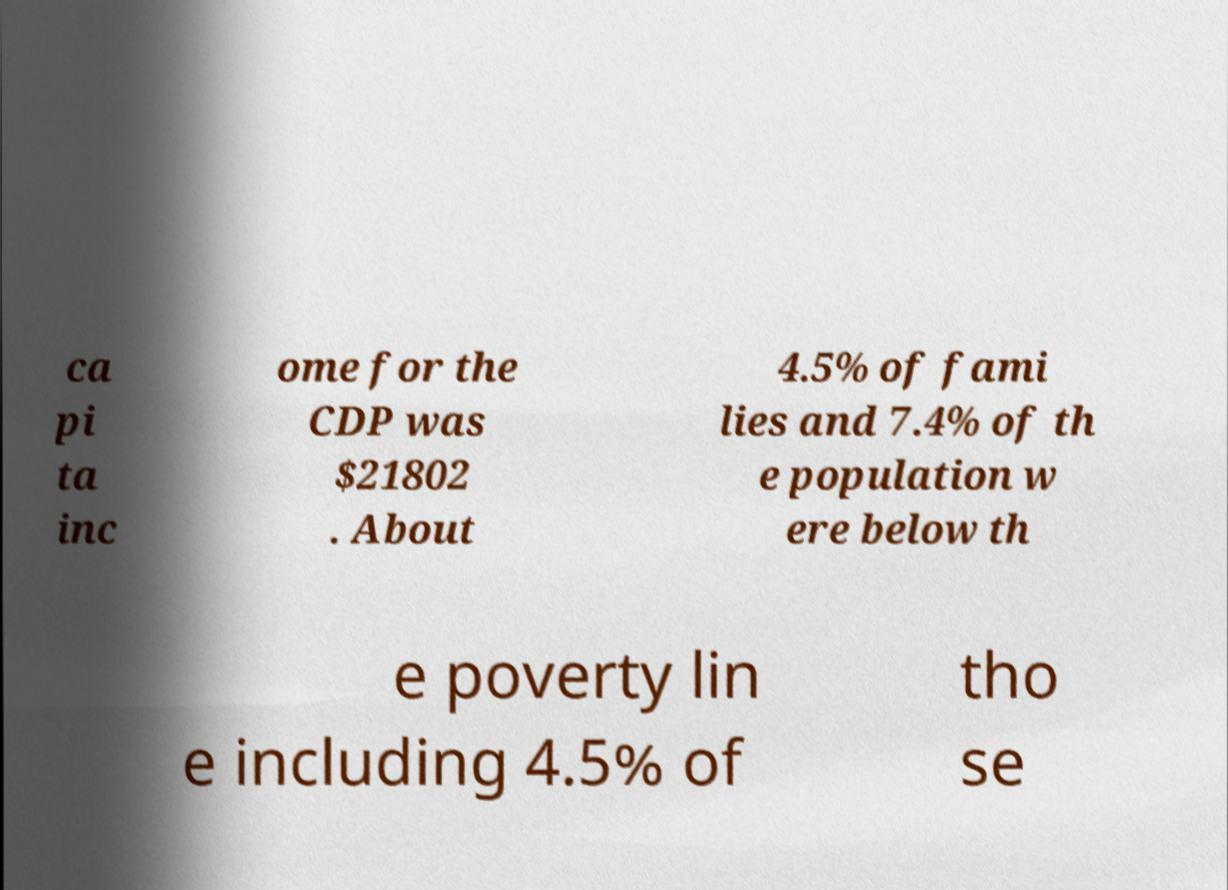Can you read and provide the text displayed in the image?This photo seems to have some interesting text. Can you extract and type it out for me? ca pi ta inc ome for the CDP was $21802 . About 4.5% of fami lies and 7.4% of th e population w ere below th e poverty lin e including 4.5% of tho se 